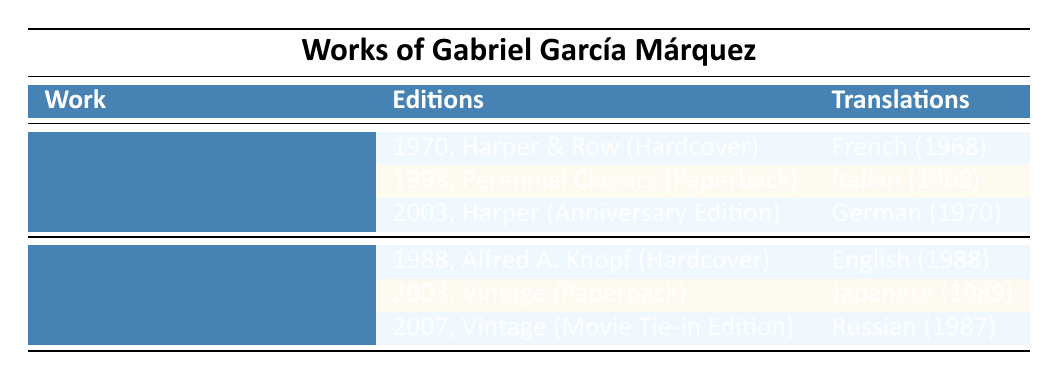What year was "One Hundred Years of Solitude" originally published? The table indicates that the original publication year for "One Hundred Years of Solitude" is listed right next to the title, which is 1967.
Answer: 1967 How many editions of "Love in the Time of Cholera" are listed? The table lists three editions under "Love in the Time of Cholera" (1985). Each edition is detailed on separate rows, confirming there are a total of three editions.
Answer: 3 What is the format of the 2003 edition of "One Hundred Years of Solitude"? The table shows the 2003 edition of "One Hundred Years of Solitude" is categorized as an "Anniversary Edition" next to the year and publisher's name.
Answer: Anniversary Edition Which language was "One Hundred Years of Solitude" first translated into? The translation section of the table lists "French" as the first language with its translation year marked as 1968, which is before any other translations.
Answer: French Did "Love in the Time of Cholera" have any paperback editions published before 2007? The table indicates that the 2003 edition of "Love in the Time of Cholera" was published in paperback format, confirming that it did have a paperback edition before 2007.
Answer: Yes What is the latest translation of "One Hundred Years of Solitude"? By checking the translations listed, the latest year for a translation of "One Hundred Years of Solitude" is 1970, which is for the German translation.
Answer: German (1970) How many total translations does "Love in the Time of Cholera" have? The table outlines three distinct translations of "Love in the Time of Cholera," each with a specific language and year, confirming there are three translations.
Answer: 3 Which work has more editions listed, "One Hundred Years of Solitude" or "Love in the Time of Cholera"? "One Hundred Years of Solitude" has three editions listed (1970, 1998, 2003), and "Love in the Time of Cholera" also has three editions (1988, 2003, 2007). Therefore, both works have an equal number of editions.
Answer: Equal What year was the first translation of "Love in the Time of Cholera" done? The table indicates that the first translation listed for "Love in the Time of Cholera" is into English by Edith Grossman in 1988.
Answer: 1988 What is the most recent edition of "One Hundred Years of Solitude"? The table shows the most recent edition of "One Hundred Years of Solitude" was published in 2003 as an "Anniversary Edition."
Answer: 2003 